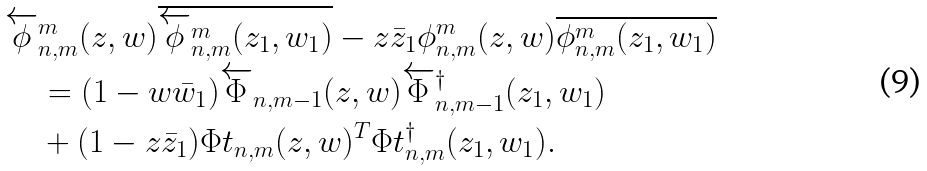Convert formula to latex. <formula><loc_0><loc_0><loc_500><loc_500>& \overleftarrow { \phi } ^ { m } _ { n , m } ( z , w ) \overline { \overleftarrow { \phi } ^ { m } _ { n , m } ( z _ { 1 } , w _ { 1 } ) } - z \bar { z } _ { 1 } \phi _ { n , m } ^ { m } ( z , w ) \overline { \phi ^ { m } _ { n , m } ( z _ { 1 } , w _ { 1 } ) } \\ & \quad = ( 1 - w \bar { w } _ { 1 } ) \overleftarrow { \Phi } _ { n , m - 1 } ( z , w ) \overleftarrow { \Phi } ^ { \dagger } _ { n , m - 1 } ( z _ { 1 } , w _ { 1 } ) \\ & \quad + ( 1 - z \bar { z } _ { 1 } ) \Phi t _ { n , m } ( z , w ) ^ { T } \Phi t ^ { \dagger } _ { n , m } ( z _ { 1 } , w _ { 1 } ) .</formula> 